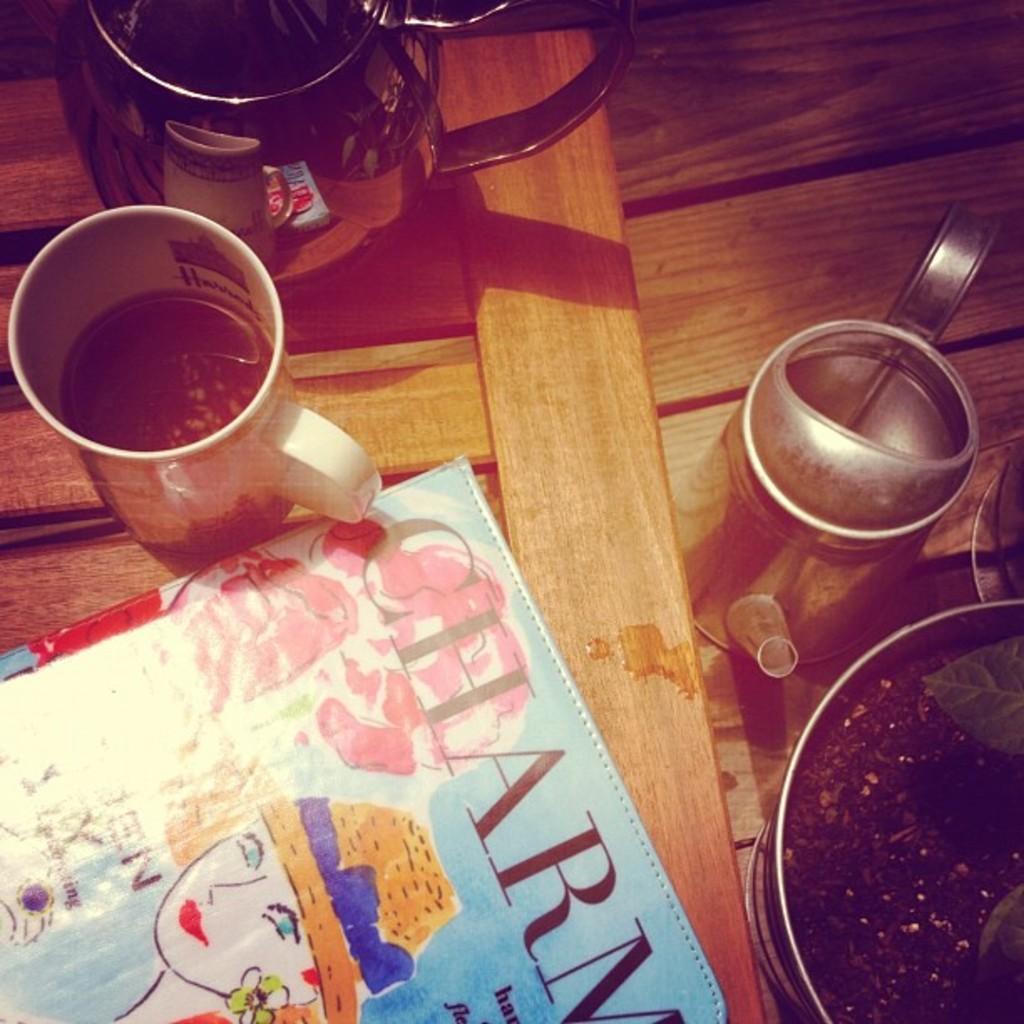Can you describe this image briefly? In this image we can see a table and on the table there are kettle, jug, coffee mug, houseplant and a book. 